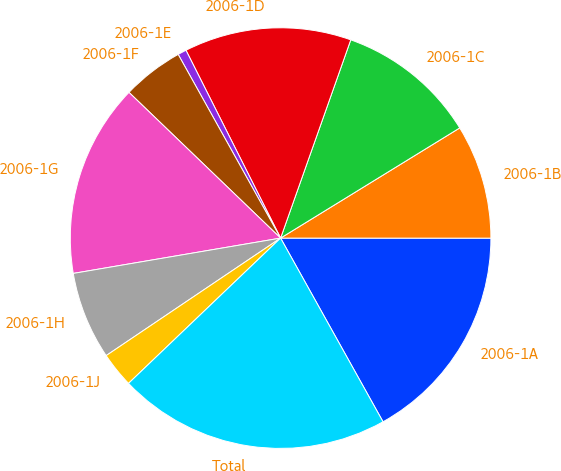Convert chart to OTSL. <chart><loc_0><loc_0><loc_500><loc_500><pie_chart><fcel>2006-1A<fcel>2006-1B<fcel>2006-1C<fcel>2006-1D<fcel>2006-1E<fcel>2006-1F<fcel>2006-1G<fcel>2006-1H<fcel>2006-1J<fcel>Total<nl><fcel>16.9%<fcel>8.78%<fcel>10.81%<fcel>12.84%<fcel>0.67%<fcel>4.72%<fcel>14.87%<fcel>6.75%<fcel>2.7%<fcel>20.96%<nl></chart> 